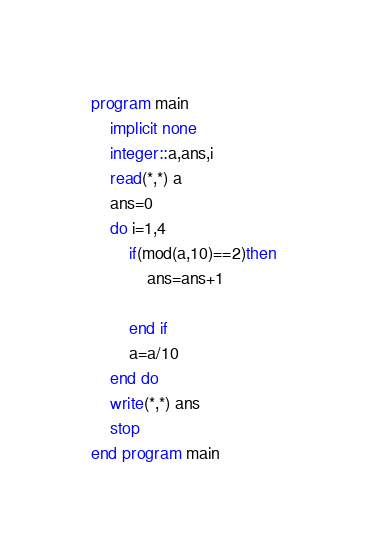Convert code to text. <code><loc_0><loc_0><loc_500><loc_500><_FORTRAN_>program main
	implicit none
    integer::a,ans,i
    read(*,*) a
    ans=0
    do i=1,4
    	if(mod(a,10)==2)then
        	ans=ans+1
            
        end if
        a=a/10
    end do
    write(*,*) ans
    stop
end program main


</code> 